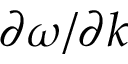Convert formula to latex. <formula><loc_0><loc_0><loc_500><loc_500>\partial \omega / \partial k</formula> 